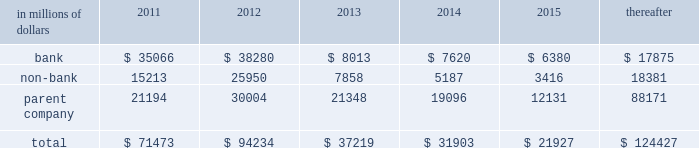Cgmhi has committed long-term financing facilities with unaffiliated banks .
At december 31 , 2010 , cgmhi had drawn down the full $ 900 million available under these facilities , of which $ 150 million is guaranteed by citigroup .
Generally , a bank can terminate these facilities by giving cgmhi one-year prior notice .
The company issues both fixed and variable rate debt in a range of currencies .
It uses derivative contracts , primarily interest rate swaps , to effectively convert a portion of its fixed rate debt to variable rate debt and variable rate debt to fixed rate debt .
The maturity structure of the derivatives generally corresponds to the maturity structure of the debt being hedged .
In addition , the company uses other derivative contracts to manage the foreign exchange impact of certain debt issuances .
At december 31 , 2010 , the company 2019s overall weighted average interest rate for long-term debt was 3.53% ( 3.53 % ) on a contractual basis and 2.78% ( 2.78 % ) including the effects of derivative contracts .
Aggregate annual maturities of long-term debt obligations ( based on final maturity dates ) including trust preferred securities are as follows : long-term debt at december 31 , 2010 and december 31 , 2009 includes $ 18131 million and $ 19345 million , respectively , of junior subordinated debt .
The company formed statutory business trusts under the laws of the state of delaware .
The trusts exist for the exclusive purposes of ( i ) issuing trust securities representing undivided beneficial interests in the assets of the trust ; ( ii ) investing the gross proceeds of the trust securities in junior subordinated deferrable interest debentures ( subordinated debentures ) of its parent ; and ( iii ) engaging in only those activities necessary or incidental thereto .
Upon approval from the federal reserve , citigroup has the right to redeem these securities .
Citigroup has contractually agreed not to redeem or purchase ( i ) the 6.50% ( 6.50 % ) enhanced trust preferred securities of citigroup capital xv before september 15 , 2056 , ( ii ) the 6.45% ( 6.45 % ) enhanced trust preferred securities of citigroup capital xvi before december 31 , 2046 , ( iii ) the 6.35% ( 6.35 % ) enhanced trust preferred securities of citigroup capital xvii before march 15 , 2057 , ( iv ) the 6.829% ( 6.829 % ) fixed rate/floating rate enhanced trust preferred securities of citigroup capital xviii before june 28 , 2047 , ( v ) the 7.250% ( 7.250 % ) enhanced trust preferred securities of citigroup capital xix before august 15 , 2047 , ( vi ) the 7.875% ( 7.875 % ) enhanced trust preferred securities of citigroup capital xx before december 15 , 2067 , and ( vii ) the 8.300% ( 8.300 % ) fixed rate/floating rate enhanced trust preferred securities of citigroup capital xxi before december 21 , 2067 , unless certain conditions , described in exhibit 4.03 to citigroup 2019s current report on form 8-k filed on september 18 , 2006 , in exhibit 4.02 to citigroup 2019s current report on form 8-k filed on november 28 , 2006 , in exhibit 4.02 to citigroup 2019s current report on form 8-k filed on march 8 , 2007 , in exhibit 4.02 to citigroup 2019s current report on form 8-k filed on july 2 , 2007 , in exhibit 4.02 to citigroup 2019s current report on form 8-k filed on august 17 , 2007 , in exhibit 4.2 to citigroup 2019s current report on form 8-k filed on november 27 , 2007 , and in exhibit 4.2 to citigroup 2019s current report on form 8-k filed on december 21 , 2007 , respectively , are met .
These agreements are for the benefit of the holders of citigroup 2019s 6.00% ( 6.00 % ) junior subordinated deferrable interest debentures due 2034 .
Citigroup owns all of the voting securities of these subsidiary trusts .
These subsidiary trusts have no assets , operations , revenues or cash flows other than those related to the issuance , administration , and repayment of the subsidiary trusts and the subsidiary trusts 2019 common securities .
These subsidiary trusts 2019 obligations are fully and unconditionally guaranteed by citigroup. .

In 2012 what percentage of total subsidiary trusts obligations are due to bank subsidiary? 
Computations: (38280 / 94234)
Answer: 0.40622. 